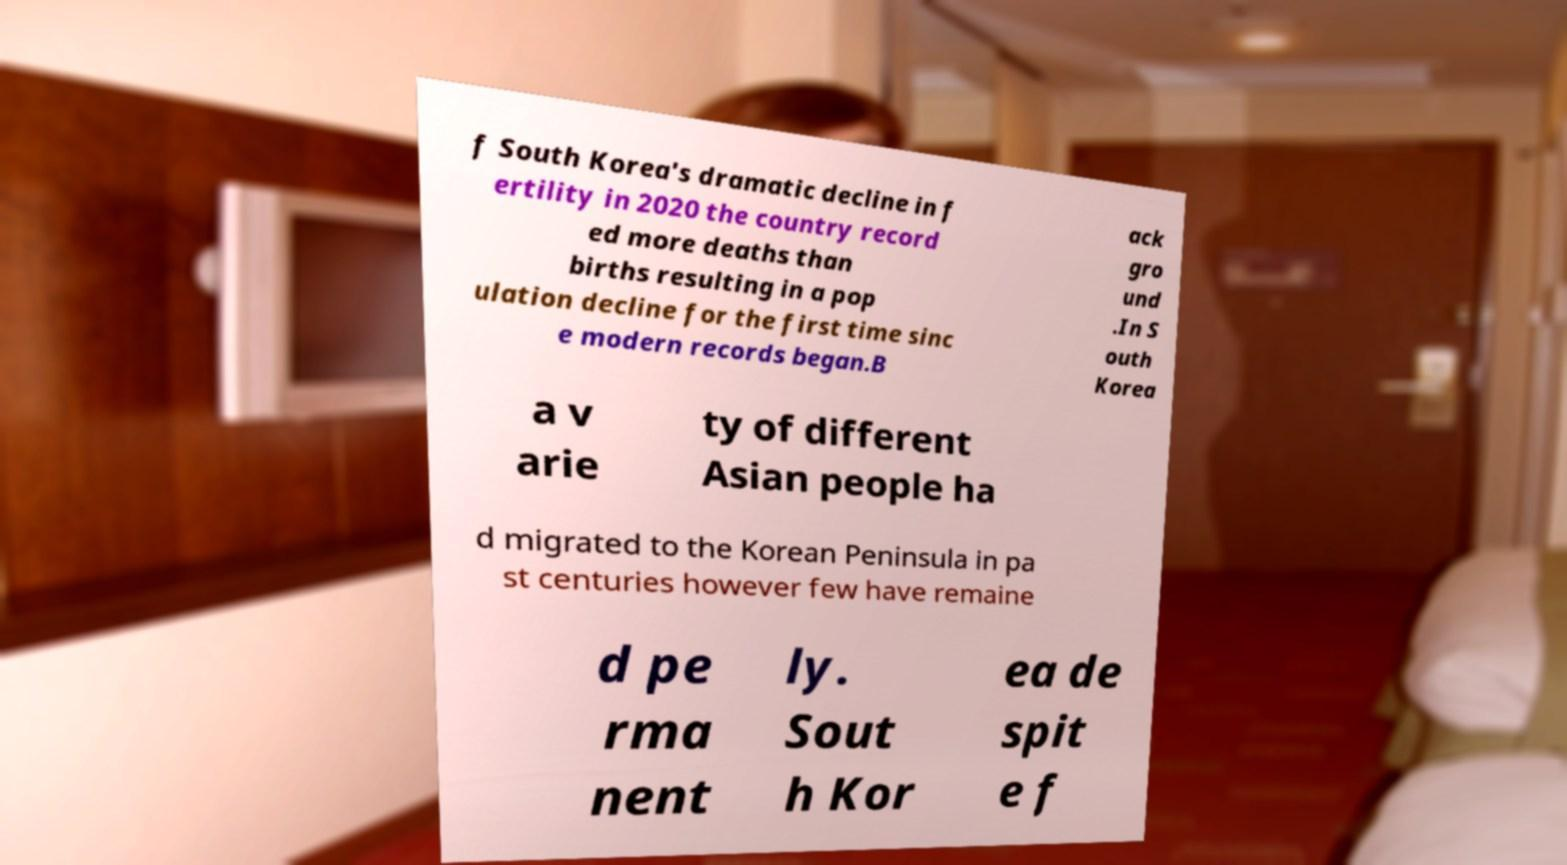Can you read and provide the text displayed in the image?This photo seems to have some interesting text. Can you extract and type it out for me? f South Korea's dramatic decline in f ertility in 2020 the country record ed more deaths than births resulting in a pop ulation decline for the first time sinc e modern records began.B ack gro und .In S outh Korea a v arie ty of different Asian people ha d migrated to the Korean Peninsula in pa st centuries however few have remaine d pe rma nent ly. Sout h Kor ea de spit e f 